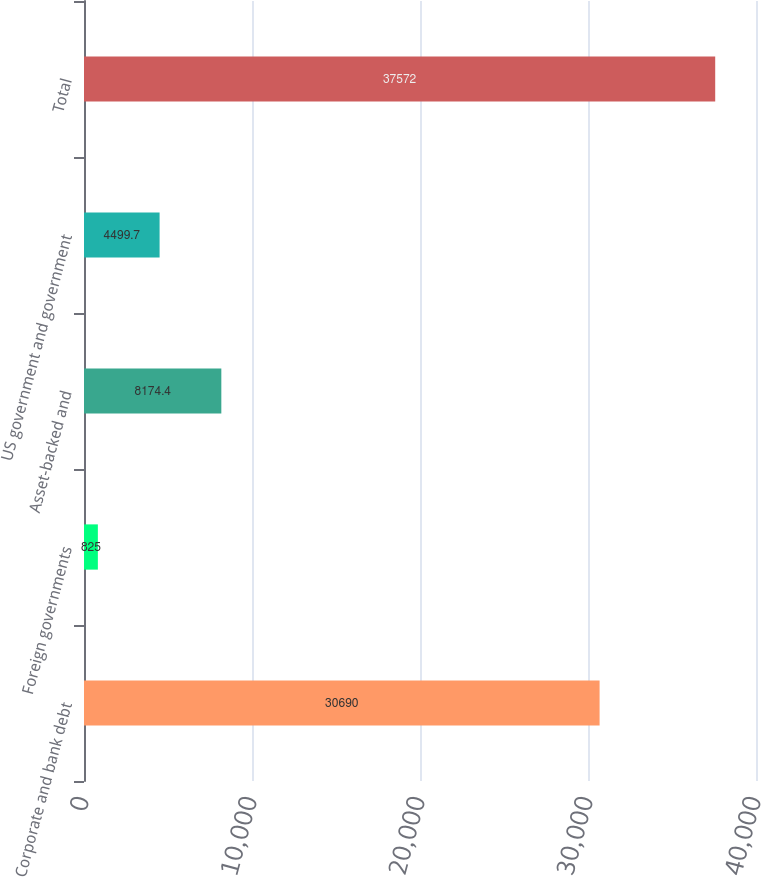Convert chart to OTSL. <chart><loc_0><loc_0><loc_500><loc_500><bar_chart><fcel>Corporate and bank debt<fcel>Foreign governments<fcel>Asset-backed and<fcel>US government and government<fcel>Total<nl><fcel>30690<fcel>825<fcel>8174.4<fcel>4499.7<fcel>37572<nl></chart> 